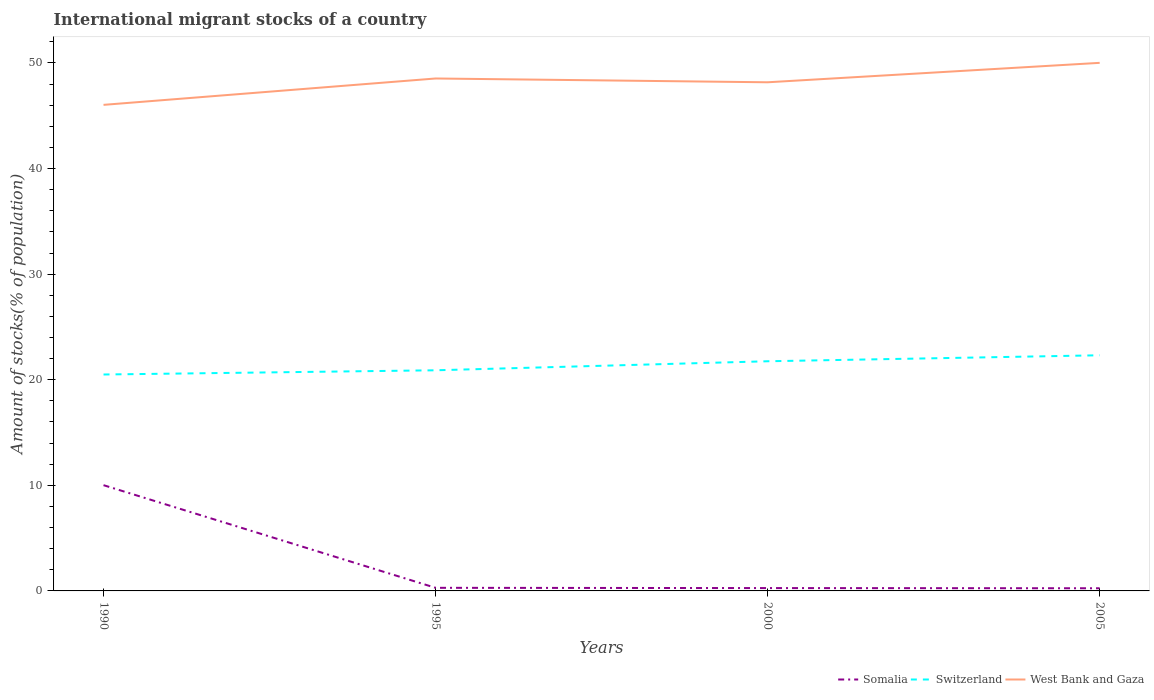Does the line corresponding to West Bank and Gaza intersect with the line corresponding to Switzerland?
Ensure brevity in your answer.  No. Across all years, what is the maximum amount of stocks in in West Bank and Gaza?
Your answer should be very brief. 46.03. In which year was the amount of stocks in in Somalia maximum?
Your answer should be very brief. 2005. What is the total amount of stocks in in Switzerland in the graph?
Your response must be concise. -1.82. What is the difference between the highest and the second highest amount of stocks in in Somalia?
Provide a succinct answer. 9.76. What is the difference between the highest and the lowest amount of stocks in in Switzerland?
Ensure brevity in your answer.  2. Is the amount of stocks in in Switzerland strictly greater than the amount of stocks in in Somalia over the years?
Offer a terse response. No. How many lines are there?
Give a very brief answer. 3. Does the graph contain any zero values?
Provide a short and direct response. No. Does the graph contain grids?
Keep it short and to the point. No. How many legend labels are there?
Offer a terse response. 3. How are the legend labels stacked?
Make the answer very short. Horizontal. What is the title of the graph?
Your answer should be very brief. International migrant stocks of a country. Does "Aruba" appear as one of the legend labels in the graph?
Your response must be concise. No. What is the label or title of the Y-axis?
Provide a short and direct response. Amount of stocks(% of population). What is the Amount of stocks(% of population) of Somalia in 1990?
Provide a short and direct response. 10.01. What is the Amount of stocks(% of population) in Switzerland in 1990?
Provide a succinct answer. 20.5. What is the Amount of stocks(% of population) of West Bank and Gaza in 1990?
Keep it short and to the point. 46.03. What is the Amount of stocks(% of population) in Somalia in 1995?
Offer a terse response. 0.29. What is the Amount of stocks(% of population) of Switzerland in 1995?
Provide a short and direct response. 20.9. What is the Amount of stocks(% of population) of West Bank and Gaza in 1995?
Your response must be concise. 48.53. What is the Amount of stocks(% of population) of Somalia in 2000?
Make the answer very short. 0.27. What is the Amount of stocks(% of population) of Switzerland in 2000?
Your answer should be compact. 21.75. What is the Amount of stocks(% of population) in West Bank and Gaza in 2000?
Your response must be concise. 48.17. What is the Amount of stocks(% of population) in Somalia in 2005?
Offer a terse response. 0.25. What is the Amount of stocks(% of population) in Switzerland in 2005?
Your answer should be compact. 22.32. What is the Amount of stocks(% of population) of West Bank and Gaza in 2005?
Provide a succinct answer. 50.01. Across all years, what is the maximum Amount of stocks(% of population) in Somalia?
Offer a terse response. 10.01. Across all years, what is the maximum Amount of stocks(% of population) of Switzerland?
Keep it short and to the point. 22.32. Across all years, what is the maximum Amount of stocks(% of population) of West Bank and Gaza?
Your answer should be compact. 50.01. Across all years, what is the minimum Amount of stocks(% of population) of Somalia?
Your answer should be compact. 0.25. Across all years, what is the minimum Amount of stocks(% of population) in Switzerland?
Offer a terse response. 20.5. Across all years, what is the minimum Amount of stocks(% of population) in West Bank and Gaza?
Your answer should be compact. 46.03. What is the total Amount of stocks(% of population) in Somalia in the graph?
Your response must be concise. 10.83. What is the total Amount of stocks(% of population) of Switzerland in the graph?
Your answer should be compact. 85.46. What is the total Amount of stocks(% of population) in West Bank and Gaza in the graph?
Keep it short and to the point. 192.75. What is the difference between the Amount of stocks(% of population) of Somalia in 1990 and that in 1995?
Offer a very short reply. 9.72. What is the difference between the Amount of stocks(% of population) in Switzerland in 1990 and that in 1995?
Ensure brevity in your answer.  -0.4. What is the difference between the Amount of stocks(% of population) of West Bank and Gaza in 1990 and that in 1995?
Your answer should be very brief. -2.5. What is the difference between the Amount of stocks(% of population) of Somalia in 1990 and that in 2000?
Your answer should be very brief. 9.75. What is the difference between the Amount of stocks(% of population) of Switzerland in 1990 and that in 2000?
Your answer should be very brief. -1.25. What is the difference between the Amount of stocks(% of population) of West Bank and Gaza in 1990 and that in 2000?
Your answer should be very brief. -2.14. What is the difference between the Amount of stocks(% of population) in Somalia in 1990 and that in 2005?
Provide a short and direct response. 9.76. What is the difference between the Amount of stocks(% of population) of Switzerland in 1990 and that in 2005?
Keep it short and to the point. -1.82. What is the difference between the Amount of stocks(% of population) of West Bank and Gaza in 1990 and that in 2005?
Your answer should be very brief. -3.98. What is the difference between the Amount of stocks(% of population) of Somalia in 1995 and that in 2000?
Give a very brief answer. 0.02. What is the difference between the Amount of stocks(% of population) of Switzerland in 1995 and that in 2000?
Make the answer very short. -0.85. What is the difference between the Amount of stocks(% of population) in West Bank and Gaza in 1995 and that in 2000?
Offer a very short reply. 0.36. What is the difference between the Amount of stocks(% of population) in Somalia in 1995 and that in 2005?
Your response must be concise. 0.04. What is the difference between the Amount of stocks(% of population) of Switzerland in 1995 and that in 2005?
Your answer should be very brief. -1.42. What is the difference between the Amount of stocks(% of population) in West Bank and Gaza in 1995 and that in 2005?
Provide a succinct answer. -1.48. What is the difference between the Amount of stocks(% of population) in Somalia in 2000 and that in 2005?
Keep it short and to the point. 0.02. What is the difference between the Amount of stocks(% of population) of Switzerland in 2000 and that in 2005?
Your answer should be very brief. -0.57. What is the difference between the Amount of stocks(% of population) of West Bank and Gaza in 2000 and that in 2005?
Your answer should be very brief. -1.84. What is the difference between the Amount of stocks(% of population) in Somalia in 1990 and the Amount of stocks(% of population) in Switzerland in 1995?
Provide a succinct answer. -10.88. What is the difference between the Amount of stocks(% of population) in Somalia in 1990 and the Amount of stocks(% of population) in West Bank and Gaza in 1995?
Provide a short and direct response. -38.52. What is the difference between the Amount of stocks(% of population) in Switzerland in 1990 and the Amount of stocks(% of population) in West Bank and Gaza in 1995?
Keep it short and to the point. -28.03. What is the difference between the Amount of stocks(% of population) of Somalia in 1990 and the Amount of stocks(% of population) of Switzerland in 2000?
Ensure brevity in your answer.  -11.74. What is the difference between the Amount of stocks(% of population) of Somalia in 1990 and the Amount of stocks(% of population) of West Bank and Gaza in 2000?
Your answer should be compact. -38.16. What is the difference between the Amount of stocks(% of population) in Switzerland in 1990 and the Amount of stocks(% of population) in West Bank and Gaza in 2000?
Give a very brief answer. -27.68. What is the difference between the Amount of stocks(% of population) of Somalia in 1990 and the Amount of stocks(% of population) of Switzerland in 2005?
Offer a terse response. -12.3. What is the difference between the Amount of stocks(% of population) in Somalia in 1990 and the Amount of stocks(% of population) in West Bank and Gaza in 2005?
Offer a terse response. -40. What is the difference between the Amount of stocks(% of population) in Switzerland in 1990 and the Amount of stocks(% of population) in West Bank and Gaza in 2005?
Your answer should be very brief. -29.52. What is the difference between the Amount of stocks(% of population) in Somalia in 1995 and the Amount of stocks(% of population) in Switzerland in 2000?
Keep it short and to the point. -21.46. What is the difference between the Amount of stocks(% of population) in Somalia in 1995 and the Amount of stocks(% of population) in West Bank and Gaza in 2000?
Offer a terse response. -47.88. What is the difference between the Amount of stocks(% of population) of Switzerland in 1995 and the Amount of stocks(% of population) of West Bank and Gaza in 2000?
Make the answer very short. -27.28. What is the difference between the Amount of stocks(% of population) of Somalia in 1995 and the Amount of stocks(% of population) of Switzerland in 2005?
Provide a short and direct response. -22.02. What is the difference between the Amount of stocks(% of population) of Somalia in 1995 and the Amount of stocks(% of population) of West Bank and Gaza in 2005?
Keep it short and to the point. -49.72. What is the difference between the Amount of stocks(% of population) in Switzerland in 1995 and the Amount of stocks(% of population) in West Bank and Gaza in 2005?
Your answer should be very brief. -29.12. What is the difference between the Amount of stocks(% of population) of Somalia in 2000 and the Amount of stocks(% of population) of Switzerland in 2005?
Offer a very short reply. -22.05. What is the difference between the Amount of stocks(% of population) in Somalia in 2000 and the Amount of stocks(% of population) in West Bank and Gaza in 2005?
Your answer should be very brief. -49.74. What is the difference between the Amount of stocks(% of population) of Switzerland in 2000 and the Amount of stocks(% of population) of West Bank and Gaza in 2005?
Provide a succinct answer. -28.26. What is the average Amount of stocks(% of population) of Somalia per year?
Give a very brief answer. 2.71. What is the average Amount of stocks(% of population) in Switzerland per year?
Give a very brief answer. 21.36. What is the average Amount of stocks(% of population) of West Bank and Gaza per year?
Make the answer very short. 48.19. In the year 1990, what is the difference between the Amount of stocks(% of population) in Somalia and Amount of stocks(% of population) in Switzerland?
Make the answer very short. -10.48. In the year 1990, what is the difference between the Amount of stocks(% of population) of Somalia and Amount of stocks(% of population) of West Bank and Gaza?
Provide a short and direct response. -36.02. In the year 1990, what is the difference between the Amount of stocks(% of population) in Switzerland and Amount of stocks(% of population) in West Bank and Gaza?
Your response must be concise. -25.54. In the year 1995, what is the difference between the Amount of stocks(% of population) of Somalia and Amount of stocks(% of population) of Switzerland?
Make the answer very short. -20.6. In the year 1995, what is the difference between the Amount of stocks(% of population) of Somalia and Amount of stocks(% of population) of West Bank and Gaza?
Make the answer very short. -48.24. In the year 1995, what is the difference between the Amount of stocks(% of population) of Switzerland and Amount of stocks(% of population) of West Bank and Gaza?
Offer a very short reply. -27.63. In the year 2000, what is the difference between the Amount of stocks(% of population) of Somalia and Amount of stocks(% of population) of Switzerland?
Provide a short and direct response. -21.48. In the year 2000, what is the difference between the Amount of stocks(% of population) in Somalia and Amount of stocks(% of population) in West Bank and Gaza?
Your answer should be very brief. -47.9. In the year 2000, what is the difference between the Amount of stocks(% of population) of Switzerland and Amount of stocks(% of population) of West Bank and Gaza?
Your answer should be very brief. -26.42. In the year 2005, what is the difference between the Amount of stocks(% of population) of Somalia and Amount of stocks(% of population) of Switzerland?
Make the answer very short. -22.07. In the year 2005, what is the difference between the Amount of stocks(% of population) in Somalia and Amount of stocks(% of population) in West Bank and Gaza?
Provide a short and direct response. -49.76. In the year 2005, what is the difference between the Amount of stocks(% of population) in Switzerland and Amount of stocks(% of population) in West Bank and Gaza?
Offer a very short reply. -27.7. What is the ratio of the Amount of stocks(% of population) in Somalia in 1990 to that in 1995?
Give a very brief answer. 34.09. What is the ratio of the Amount of stocks(% of population) of Switzerland in 1990 to that in 1995?
Provide a short and direct response. 0.98. What is the ratio of the Amount of stocks(% of population) of West Bank and Gaza in 1990 to that in 1995?
Offer a very short reply. 0.95. What is the ratio of the Amount of stocks(% of population) of Somalia in 1990 to that in 2000?
Keep it short and to the point. 37.22. What is the ratio of the Amount of stocks(% of population) in Switzerland in 1990 to that in 2000?
Your answer should be very brief. 0.94. What is the ratio of the Amount of stocks(% of population) in West Bank and Gaza in 1990 to that in 2000?
Offer a very short reply. 0.96. What is the ratio of the Amount of stocks(% of population) in Somalia in 1990 to that in 2005?
Your answer should be very brief. 39.86. What is the ratio of the Amount of stocks(% of population) of Switzerland in 1990 to that in 2005?
Provide a succinct answer. 0.92. What is the ratio of the Amount of stocks(% of population) of West Bank and Gaza in 1990 to that in 2005?
Your answer should be compact. 0.92. What is the ratio of the Amount of stocks(% of population) in Somalia in 1995 to that in 2000?
Give a very brief answer. 1.09. What is the ratio of the Amount of stocks(% of population) of Switzerland in 1995 to that in 2000?
Offer a terse response. 0.96. What is the ratio of the Amount of stocks(% of population) of West Bank and Gaza in 1995 to that in 2000?
Offer a terse response. 1.01. What is the ratio of the Amount of stocks(% of population) in Somalia in 1995 to that in 2005?
Offer a very short reply. 1.17. What is the ratio of the Amount of stocks(% of population) of Switzerland in 1995 to that in 2005?
Your answer should be compact. 0.94. What is the ratio of the Amount of stocks(% of population) of West Bank and Gaza in 1995 to that in 2005?
Ensure brevity in your answer.  0.97. What is the ratio of the Amount of stocks(% of population) in Somalia in 2000 to that in 2005?
Give a very brief answer. 1.07. What is the ratio of the Amount of stocks(% of population) of Switzerland in 2000 to that in 2005?
Provide a short and direct response. 0.97. What is the ratio of the Amount of stocks(% of population) in West Bank and Gaza in 2000 to that in 2005?
Offer a very short reply. 0.96. What is the difference between the highest and the second highest Amount of stocks(% of population) in Somalia?
Ensure brevity in your answer.  9.72. What is the difference between the highest and the second highest Amount of stocks(% of population) in Switzerland?
Provide a succinct answer. 0.57. What is the difference between the highest and the second highest Amount of stocks(% of population) of West Bank and Gaza?
Your response must be concise. 1.48. What is the difference between the highest and the lowest Amount of stocks(% of population) of Somalia?
Offer a very short reply. 9.76. What is the difference between the highest and the lowest Amount of stocks(% of population) in Switzerland?
Your answer should be very brief. 1.82. What is the difference between the highest and the lowest Amount of stocks(% of population) in West Bank and Gaza?
Your answer should be very brief. 3.98. 